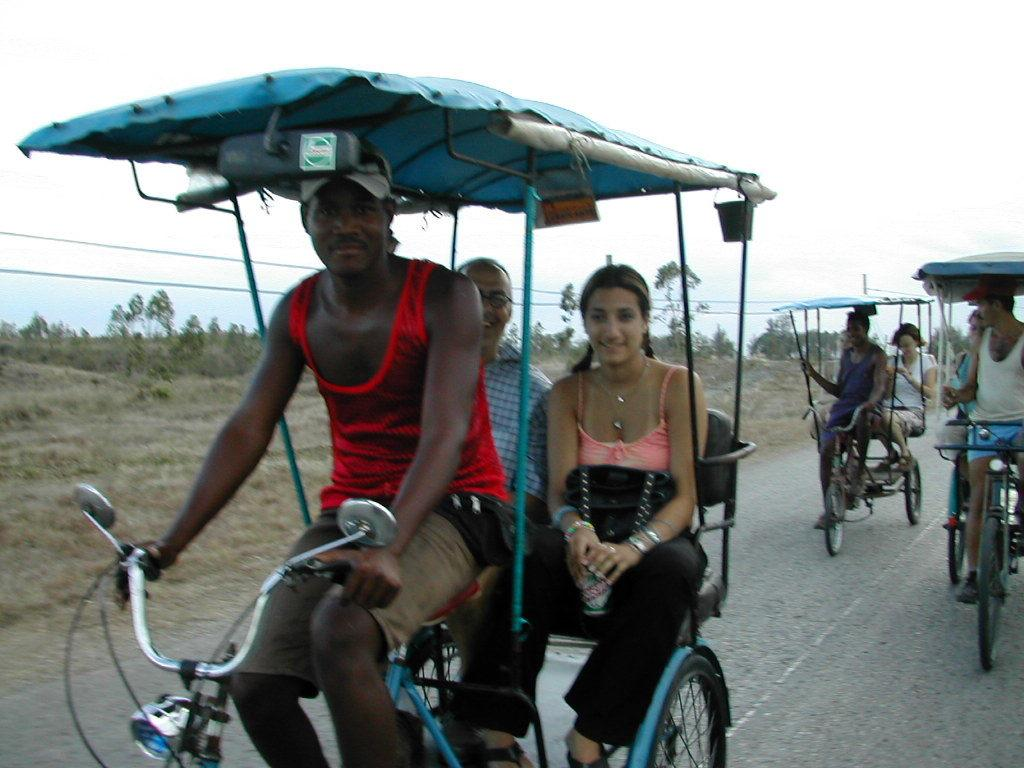What activity is being performed by the people in the image? The people are setting up a rickshaw in the image. What type of rickshaw is being set up? The rickshaw is an hour rickshaw. What can be seen in the background of the image? There are trees and the sky visible in the background of the image. What type of furniture is being used to decorate the rickshaw in the image? There is no furniture present in the image; it features people setting up an hour rickshaw. 